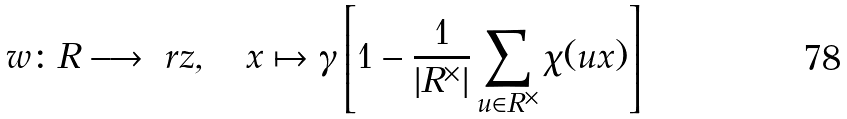<formula> <loc_0><loc_0><loc_500><loc_500>w \colon R \longrightarrow \ r z , \quad x \mapsto \gamma \left [ 1 - \frac { 1 } { | R ^ { \times } | } \sum _ { u \in R ^ { \times } } \chi ( u x ) \right ]</formula> 